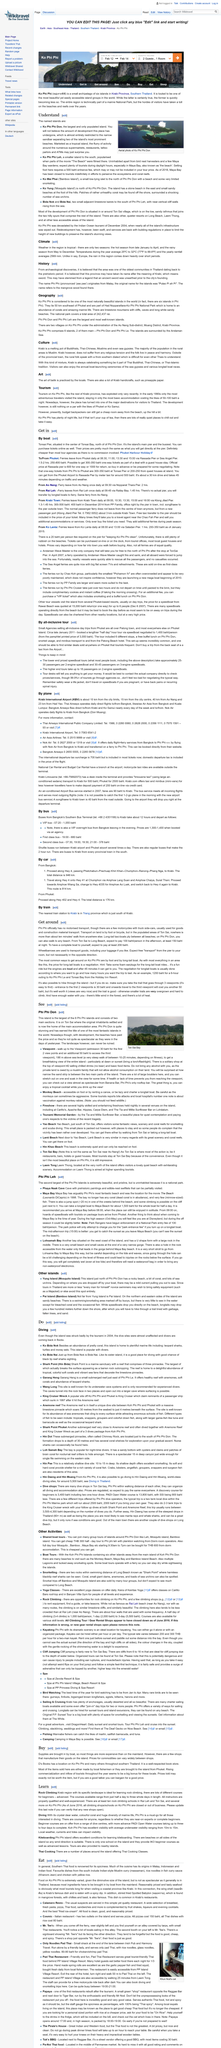Draw attention to some important aspects in this diagram. Tonsai Pier is located in the center of Tonsai Bay, on the northern coast of Phi Phi Don Island. D's book reports that items sold in the market are either produced by local fishermen or brought in from Phuket. Phi Phi Don, comprised of two main sections, is made up of two main sections. The movie that was filmed in parts of Ko Phi Phi Leh, including the beach, is known for its scenic cinematography of the island. It is possible to visit Monkey Beach, Maya Bay and Bamboo Island Beach during boat tours, providing a variety of opportunities for beachgoers to enjoy the stunning scenery and crystal clear waters of the region. 